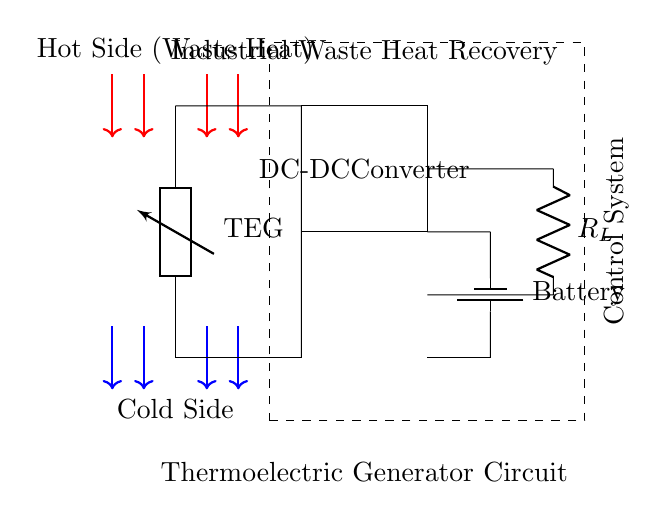What type of generator is shown? The circuit contains a TEG, which stands for Thermoelectric Generator, used for converting heat energy into electrical energy.
Answer: Thermoelectric Generator What does the dashed rectangle represent? The dashed rectangle encloses the control system, indicating that it manages or regulates the operation of the circuit components, particularly the power output and battery management.
Answer: Control System What is being recovered in this circuit? The circuit is designed for industrial waste heat recovery, utilizing heat that would otherwise be lost in industrial processes.
Answer: Waste Heat What is the component labeled as "R_L"? "R_L" refers to the load resistor in the circuit, which represents the electrical load that the circuit is powering using the converted energy from the TEG.
Answer: Load Resistor What is the purpose of the DC-DC converter? The DC-DC converter in the circuit is designed to adjust the voltage levels from the TEG to a usable level for charging the battery and supplying the load.
Answer: Adjust voltage levels Which side is indicated as the hot side? The hot side, where the waste heat source applies heat, is indicated at the top of the circuit diagram, where the arrows point towards the Thermoelectric Generator.
Answer: Hot Side 